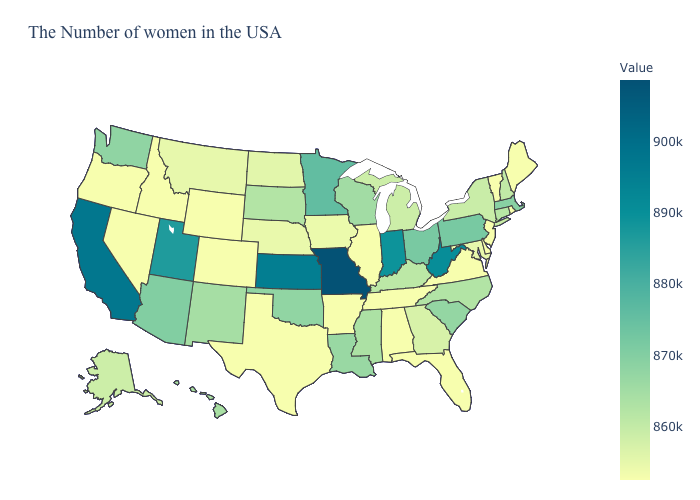Which states have the lowest value in the USA?
Keep it brief. Maine, Rhode Island, Vermont, New Jersey, Delaware, Virginia, Florida, Alabama, Tennessee, Illinois, Arkansas, Texas, Wyoming, Colorado, Idaho, Nevada, Oregon. Among the states that border Delaware , does New Jersey have the highest value?
Give a very brief answer. No. Among the states that border Utah , which have the lowest value?
Keep it brief. Wyoming, Colorado, Idaho, Nevada. Does Maine have the highest value in the USA?
Concise answer only. No. Does Arkansas have a higher value than Wisconsin?
Answer briefly. No. Is the legend a continuous bar?
Answer briefly. Yes. 